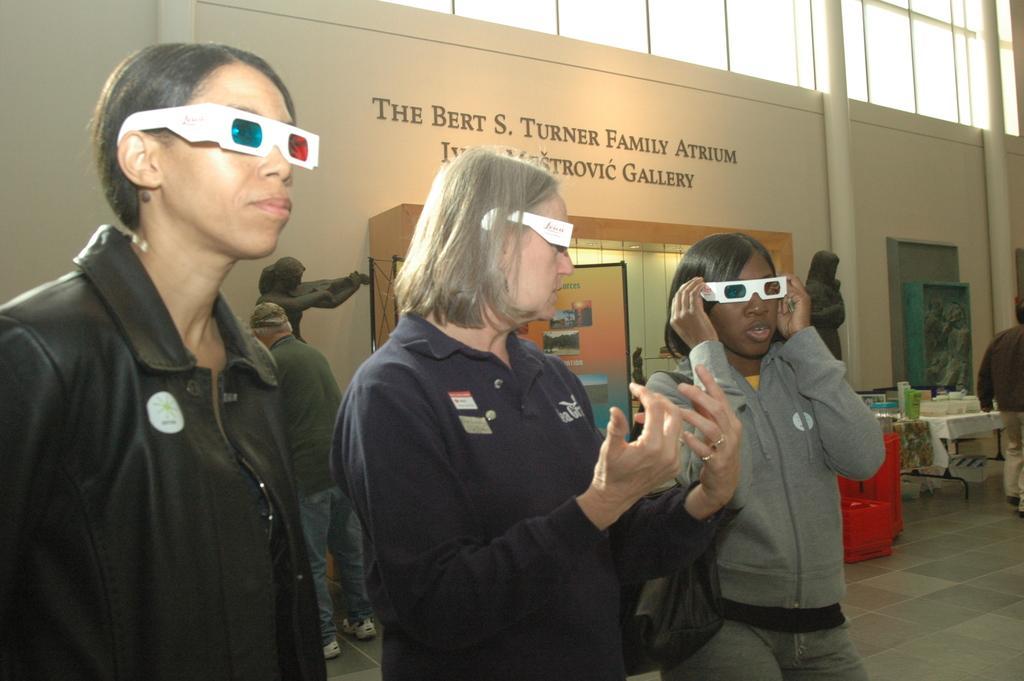How would you summarize this image in a sentence or two? In the image we can see there are people standing and they are wearing 3D glasses. Behind there other people standing and they are boxes kept on the table. There is a matter written on the building. 